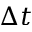<formula> <loc_0><loc_0><loc_500><loc_500>\Delta t</formula> 